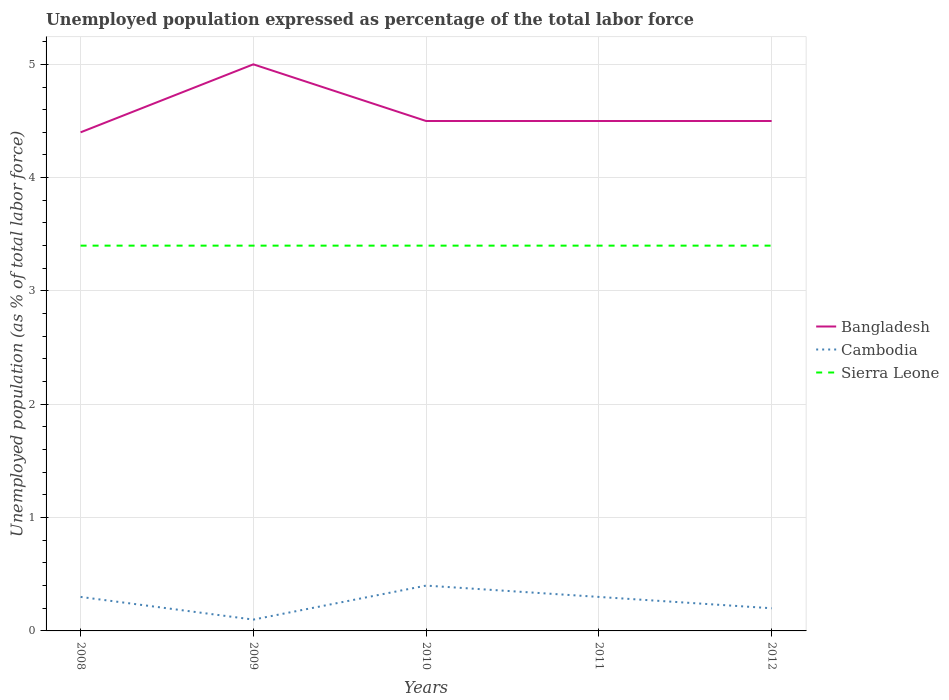How many different coloured lines are there?
Your answer should be compact. 3. Is the number of lines equal to the number of legend labels?
Your response must be concise. Yes. Across all years, what is the maximum unemployment in in Cambodia?
Offer a terse response. 0.1. What is the total unemployment in in Cambodia in the graph?
Make the answer very short. -0.1. What is the difference between the highest and the second highest unemployment in in Bangladesh?
Your answer should be compact. 0.6. What is the difference between two consecutive major ticks on the Y-axis?
Your answer should be very brief. 1. Where does the legend appear in the graph?
Provide a short and direct response. Center right. How many legend labels are there?
Ensure brevity in your answer.  3. How are the legend labels stacked?
Provide a succinct answer. Vertical. What is the title of the graph?
Provide a short and direct response. Unemployed population expressed as percentage of the total labor force. What is the label or title of the X-axis?
Offer a very short reply. Years. What is the label or title of the Y-axis?
Offer a terse response. Unemployed population (as % of total labor force). What is the Unemployed population (as % of total labor force) of Bangladesh in 2008?
Make the answer very short. 4.4. What is the Unemployed population (as % of total labor force) of Cambodia in 2008?
Offer a very short reply. 0.3. What is the Unemployed population (as % of total labor force) of Sierra Leone in 2008?
Give a very brief answer. 3.4. What is the Unemployed population (as % of total labor force) of Cambodia in 2009?
Your answer should be very brief. 0.1. What is the Unemployed population (as % of total labor force) in Sierra Leone in 2009?
Ensure brevity in your answer.  3.4. What is the Unemployed population (as % of total labor force) of Bangladesh in 2010?
Your answer should be compact. 4.5. What is the Unemployed population (as % of total labor force) of Cambodia in 2010?
Offer a terse response. 0.4. What is the Unemployed population (as % of total labor force) of Sierra Leone in 2010?
Offer a terse response. 3.4. What is the Unemployed population (as % of total labor force) in Cambodia in 2011?
Offer a terse response. 0.3. What is the Unemployed population (as % of total labor force) in Sierra Leone in 2011?
Keep it short and to the point. 3.4. What is the Unemployed population (as % of total labor force) of Cambodia in 2012?
Make the answer very short. 0.2. What is the Unemployed population (as % of total labor force) in Sierra Leone in 2012?
Make the answer very short. 3.4. Across all years, what is the maximum Unemployed population (as % of total labor force) in Bangladesh?
Your answer should be very brief. 5. Across all years, what is the maximum Unemployed population (as % of total labor force) in Cambodia?
Offer a very short reply. 0.4. Across all years, what is the maximum Unemployed population (as % of total labor force) of Sierra Leone?
Your answer should be very brief. 3.4. Across all years, what is the minimum Unemployed population (as % of total labor force) in Bangladesh?
Your answer should be compact. 4.4. Across all years, what is the minimum Unemployed population (as % of total labor force) of Cambodia?
Provide a short and direct response. 0.1. Across all years, what is the minimum Unemployed population (as % of total labor force) in Sierra Leone?
Make the answer very short. 3.4. What is the total Unemployed population (as % of total labor force) in Bangladesh in the graph?
Your response must be concise. 22.9. What is the total Unemployed population (as % of total labor force) of Cambodia in the graph?
Provide a succinct answer. 1.3. What is the difference between the Unemployed population (as % of total labor force) in Sierra Leone in 2008 and that in 2009?
Keep it short and to the point. 0. What is the difference between the Unemployed population (as % of total labor force) of Bangladesh in 2008 and that in 2010?
Your answer should be very brief. -0.1. What is the difference between the Unemployed population (as % of total labor force) of Cambodia in 2008 and that in 2010?
Keep it short and to the point. -0.1. What is the difference between the Unemployed population (as % of total labor force) in Sierra Leone in 2008 and that in 2010?
Provide a short and direct response. 0. What is the difference between the Unemployed population (as % of total labor force) of Sierra Leone in 2008 and that in 2011?
Keep it short and to the point. 0. What is the difference between the Unemployed population (as % of total labor force) in Cambodia in 2008 and that in 2012?
Your answer should be compact. 0.1. What is the difference between the Unemployed population (as % of total labor force) in Bangladesh in 2009 and that in 2010?
Provide a short and direct response. 0.5. What is the difference between the Unemployed population (as % of total labor force) in Cambodia in 2009 and that in 2010?
Make the answer very short. -0.3. What is the difference between the Unemployed population (as % of total labor force) of Sierra Leone in 2009 and that in 2010?
Give a very brief answer. 0. What is the difference between the Unemployed population (as % of total labor force) of Bangladesh in 2009 and that in 2011?
Give a very brief answer. 0.5. What is the difference between the Unemployed population (as % of total labor force) in Sierra Leone in 2009 and that in 2011?
Your answer should be very brief. 0. What is the difference between the Unemployed population (as % of total labor force) of Bangladesh in 2009 and that in 2012?
Offer a very short reply. 0.5. What is the difference between the Unemployed population (as % of total labor force) in Cambodia in 2009 and that in 2012?
Your answer should be very brief. -0.1. What is the difference between the Unemployed population (as % of total labor force) in Sierra Leone in 2009 and that in 2012?
Offer a very short reply. 0. What is the difference between the Unemployed population (as % of total labor force) of Cambodia in 2010 and that in 2011?
Offer a very short reply. 0.1. What is the difference between the Unemployed population (as % of total labor force) in Sierra Leone in 2010 and that in 2011?
Your answer should be compact. 0. What is the difference between the Unemployed population (as % of total labor force) in Cambodia in 2011 and that in 2012?
Make the answer very short. 0.1. What is the difference between the Unemployed population (as % of total labor force) of Sierra Leone in 2011 and that in 2012?
Your response must be concise. 0. What is the difference between the Unemployed population (as % of total labor force) of Bangladesh in 2008 and the Unemployed population (as % of total labor force) of Sierra Leone in 2011?
Ensure brevity in your answer.  1. What is the difference between the Unemployed population (as % of total labor force) of Bangladesh in 2008 and the Unemployed population (as % of total labor force) of Cambodia in 2012?
Give a very brief answer. 4.2. What is the difference between the Unemployed population (as % of total labor force) of Cambodia in 2008 and the Unemployed population (as % of total labor force) of Sierra Leone in 2012?
Provide a succinct answer. -3.1. What is the difference between the Unemployed population (as % of total labor force) in Bangladesh in 2009 and the Unemployed population (as % of total labor force) in Cambodia in 2010?
Keep it short and to the point. 4.6. What is the difference between the Unemployed population (as % of total labor force) in Bangladesh in 2009 and the Unemployed population (as % of total labor force) in Sierra Leone in 2010?
Provide a short and direct response. 1.6. What is the difference between the Unemployed population (as % of total labor force) in Cambodia in 2009 and the Unemployed population (as % of total labor force) in Sierra Leone in 2010?
Your answer should be very brief. -3.3. What is the difference between the Unemployed population (as % of total labor force) of Bangladesh in 2009 and the Unemployed population (as % of total labor force) of Cambodia in 2011?
Provide a short and direct response. 4.7. What is the difference between the Unemployed population (as % of total labor force) of Cambodia in 2009 and the Unemployed population (as % of total labor force) of Sierra Leone in 2011?
Ensure brevity in your answer.  -3.3. What is the difference between the Unemployed population (as % of total labor force) in Bangladesh in 2009 and the Unemployed population (as % of total labor force) in Cambodia in 2012?
Offer a terse response. 4.8. What is the difference between the Unemployed population (as % of total labor force) of Bangladesh in 2010 and the Unemployed population (as % of total labor force) of Cambodia in 2012?
Your answer should be compact. 4.3. What is the difference between the Unemployed population (as % of total labor force) of Bangladesh in 2010 and the Unemployed population (as % of total labor force) of Sierra Leone in 2012?
Make the answer very short. 1.1. What is the difference between the Unemployed population (as % of total labor force) in Bangladesh in 2011 and the Unemployed population (as % of total labor force) in Cambodia in 2012?
Keep it short and to the point. 4.3. What is the difference between the Unemployed population (as % of total labor force) in Cambodia in 2011 and the Unemployed population (as % of total labor force) in Sierra Leone in 2012?
Provide a succinct answer. -3.1. What is the average Unemployed population (as % of total labor force) in Bangladesh per year?
Give a very brief answer. 4.58. What is the average Unemployed population (as % of total labor force) of Cambodia per year?
Offer a terse response. 0.26. In the year 2008, what is the difference between the Unemployed population (as % of total labor force) in Bangladesh and Unemployed population (as % of total labor force) in Cambodia?
Keep it short and to the point. 4.1. In the year 2008, what is the difference between the Unemployed population (as % of total labor force) of Bangladesh and Unemployed population (as % of total labor force) of Sierra Leone?
Offer a terse response. 1. In the year 2008, what is the difference between the Unemployed population (as % of total labor force) of Cambodia and Unemployed population (as % of total labor force) of Sierra Leone?
Make the answer very short. -3.1. In the year 2009, what is the difference between the Unemployed population (as % of total labor force) of Bangladesh and Unemployed population (as % of total labor force) of Cambodia?
Give a very brief answer. 4.9. In the year 2009, what is the difference between the Unemployed population (as % of total labor force) of Bangladesh and Unemployed population (as % of total labor force) of Sierra Leone?
Ensure brevity in your answer.  1.6. In the year 2010, what is the difference between the Unemployed population (as % of total labor force) of Bangladesh and Unemployed population (as % of total labor force) of Cambodia?
Keep it short and to the point. 4.1. In the year 2010, what is the difference between the Unemployed population (as % of total labor force) in Bangladesh and Unemployed population (as % of total labor force) in Sierra Leone?
Ensure brevity in your answer.  1.1. In the year 2010, what is the difference between the Unemployed population (as % of total labor force) in Cambodia and Unemployed population (as % of total labor force) in Sierra Leone?
Your answer should be compact. -3. In the year 2012, what is the difference between the Unemployed population (as % of total labor force) in Bangladesh and Unemployed population (as % of total labor force) in Cambodia?
Provide a short and direct response. 4.3. What is the ratio of the Unemployed population (as % of total labor force) in Bangladesh in 2008 to that in 2009?
Ensure brevity in your answer.  0.88. What is the ratio of the Unemployed population (as % of total labor force) in Bangladesh in 2008 to that in 2010?
Offer a very short reply. 0.98. What is the ratio of the Unemployed population (as % of total labor force) in Sierra Leone in 2008 to that in 2010?
Give a very brief answer. 1. What is the ratio of the Unemployed population (as % of total labor force) of Bangladesh in 2008 to that in 2011?
Make the answer very short. 0.98. What is the ratio of the Unemployed population (as % of total labor force) of Cambodia in 2008 to that in 2011?
Keep it short and to the point. 1. What is the ratio of the Unemployed population (as % of total labor force) of Sierra Leone in 2008 to that in 2011?
Your answer should be compact. 1. What is the ratio of the Unemployed population (as % of total labor force) in Bangladesh in 2008 to that in 2012?
Offer a very short reply. 0.98. What is the ratio of the Unemployed population (as % of total labor force) in Sierra Leone in 2008 to that in 2012?
Ensure brevity in your answer.  1. What is the ratio of the Unemployed population (as % of total labor force) in Bangladesh in 2009 to that in 2012?
Offer a terse response. 1.11. What is the ratio of the Unemployed population (as % of total labor force) of Cambodia in 2009 to that in 2012?
Provide a short and direct response. 0.5. What is the ratio of the Unemployed population (as % of total labor force) of Sierra Leone in 2009 to that in 2012?
Ensure brevity in your answer.  1. What is the ratio of the Unemployed population (as % of total labor force) in Bangladesh in 2010 to that in 2011?
Give a very brief answer. 1. What is the ratio of the Unemployed population (as % of total labor force) in Bangladesh in 2010 to that in 2012?
Give a very brief answer. 1. What is the ratio of the Unemployed population (as % of total labor force) of Sierra Leone in 2010 to that in 2012?
Ensure brevity in your answer.  1. What is the ratio of the Unemployed population (as % of total labor force) of Bangladesh in 2011 to that in 2012?
Your answer should be very brief. 1. What is the ratio of the Unemployed population (as % of total labor force) in Cambodia in 2011 to that in 2012?
Offer a terse response. 1.5. What is the ratio of the Unemployed population (as % of total labor force) of Sierra Leone in 2011 to that in 2012?
Provide a short and direct response. 1. What is the difference between the highest and the second highest Unemployed population (as % of total labor force) in Cambodia?
Your answer should be compact. 0.1. What is the difference between the highest and the lowest Unemployed population (as % of total labor force) in Cambodia?
Give a very brief answer. 0.3. 